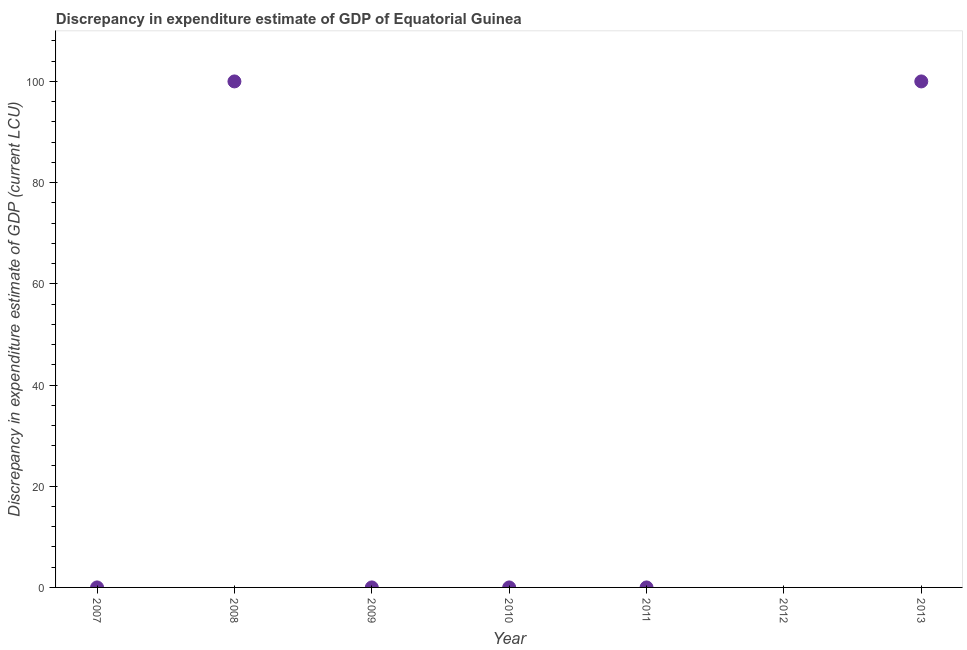What is the discrepancy in expenditure estimate of gdp in 2009?
Provide a short and direct response. 0. Across all years, what is the maximum discrepancy in expenditure estimate of gdp?
Ensure brevity in your answer.  100. In which year was the discrepancy in expenditure estimate of gdp maximum?
Provide a short and direct response. 2008. What is the sum of the discrepancy in expenditure estimate of gdp?
Your answer should be compact. 200. What is the difference between the discrepancy in expenditure estimate of gdp in 2007 and 2013?
Offer a terse response. -100. What is the average discrepancy in expenditure estimate of gdp per year?
Keep it short and to the point. 28.57. What is the median discrepancy in expenditure estimate of gdp?
Keep it short and to the point. 0. In how many years, is the discrepancy in expenditure estimate of gdp greater than 64 LCU?
Keep it short and to the point. 2. What is the ratio of the discrepancy in expenditure estimate of gdp in 2007 to that in 2009?
Offer a very short reply. 1.33. Is the discrepancy in expenditure estimate of gdp in 2007 less than that in 2013?
Your answer should be very brief. Yes. What is the difference between the highest and the second highest discrepancy in expenditure estimate of gdp?
Offer a very short reply. 0. Is the sum of the discrepancy in expenditure estimate of gdp in 2008 and 2013 greater than the maximum discrepancy in expenditure estimate of gdp across all years?
Your answer should be very brief. Yes. What is the difference between the highest and the lowest discrepancy in expenditure estimate of gdp?
Your answer should be very brief. 100. In how many years, is the discrepancy in expenditure estimate of gdp greater than the average discrepancy in expenditure estimate of gdp taken over all years?
Provide a short and direct response. 2. Does the discrepancy in expenditure estimate of gdp monotonically increase over the years?
Offer a terse response. No. How many dotlines are there?
Make the answer very short. 1. How many years are there in the graph?
Offer a terse response. 7. Does the graph contain grids?
Provide a succinct answer. No. What is the title of the graph?
Your answer should be very brief. Discrepancy in expenditure estimate of GDP of Equatorial Guinea. What is the label or title of the Y-axis?
Provide a short and direct response. Discrepancy in expenditure estimate of GDP (current LCU). What is the Discrepancy in expenditure estimate of GDP (current LCU) in 2007?
Your answer should be compact. 0. What is the Discrepancy in expenditure estimate of GDP (current LCU) in 2008?
Provide a short and direct response. 100. What is the Discrepancy in expenditure estimate of GDP (current LCU) in 2009?
Ensure brevity in your answer.  0. What is the Discrepancy in expenditure estimate of GDP (current LCU) in 2010?
Provide a short and direct response. 0. What is the Discrepancy in expenditure estimate of GDP (current LCU) in 2011?
Give a very brief answer. 0. What is the Discrepancy in expenditure estimate of GDP (current LCU) in 2012?
Give a very brief answer. 0. What is the Discrepancy in expenditure estimate of GDP (current LCU) in 2013?
Make the answer very short. 100. What is the difference between the Discrepancy in expenditure estimate of GDP (current LCU) in 2007 and 2008?
Your answer should be very brief. -100. What is the difference between the Discrepancy in expenditure estimate of GDP (current LCU) in 2007 and 2009?
Ensure brevity in your answer.  0. What is the difference between the Discrepancy in expenditure estimate of GDP (current LCU) in 2007 and 2013?
Ensure brevity in your answer.  -100. What is the difference between the Discrepancy in expenditure estimate of GDP (current LCU) in 2008 and 2009?
Give a very brief answer. 100. What is the difference between the Discrepancy in expenditure estimate of GDP (current LCU) in 2008 and 2013?
Provide a succinct answer. 0. What is the difference between the Discrepancy in expenditure estimate of GDP (current LCU) in 2009 and 2013?
Your answer should be very brief. -100. What is the ratio of the Discrepancy in expenditure estimate of GDP (current LCU) in 2007 to that in 2009?
Make the answer very short. 1.33. What is the ratio of the Discrepancy in expenditure estimate of GDP (current LCU) in 2007 to that in 2013?
Give a very brief answer. 0. What is the ratio of the Discrepancy in expenditure estimate of GDP (current LCU) in 2008 to that in 2009?
Offer a very short reply. 2.86e+05. 